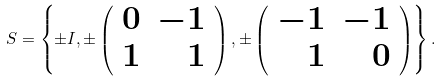<formula> <loc_0><loc_0><loc_500><loc_500>S = \left \{ \pm I , \pm \left ( \begin{array} { r r } 0 & - 1 \\ 1 & 1 \end{array} \right ) , \pm \left ( \begin{array} { r r } - 1 & - 1 \\ 1 & 0 \end{array} \right ) \right \} .</formula> 